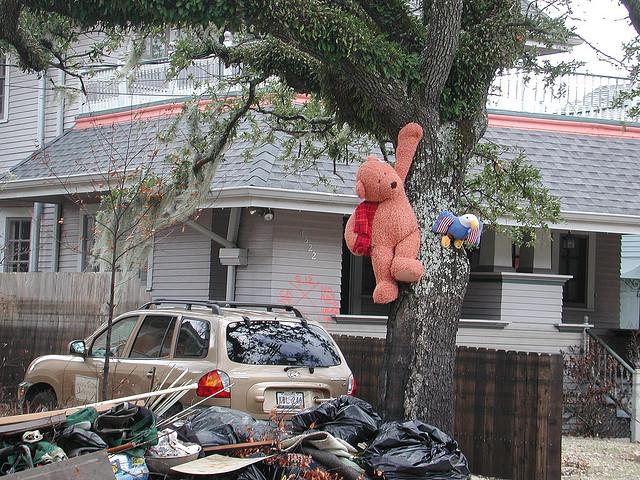While is the pile of stuff on the bottom left?
Keep it brief. Trash. Are they alive?
Answer briefly. No. How many animals are in the tree?
Keep it brief. 2. 